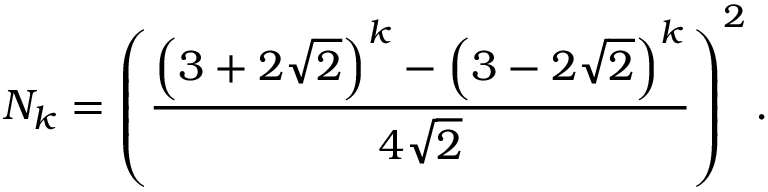Convert formula to latex. <formula><loc_0><loc_0><loc_500><loc_500>N _ { k } = \left ( { \frac { \left ( 3 + 2 { \sqrt { 2 } } \right ) ^ { k } - \left ( 3 - 2 { \sqrt { 2 } } \right ) ^ { k } } { 4 { \sqrt { 2 } } } } \right ) ^ { 2 } .</formula> 